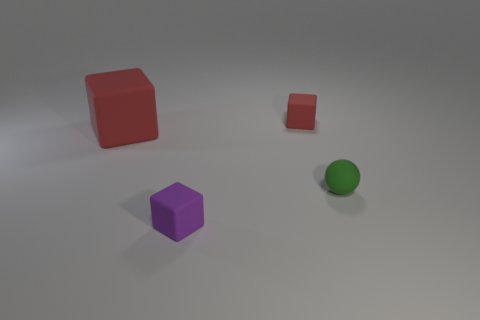Do the tiny sphere and the red object left of the small red object have the same material?
Your answer should be compact. Yes. What is the shape of the green thing behind the purple thing?
Offer a very short reply. Sphere. Is the number of matte things the same as the number of tiny red balls?
Make the answer very short. No. How many other objects are there of the same material as the small sphere?
Provide a succinct answer. 3. How big is the purple rubber block?
Provide a short and direct response. Small. What number of other things are there of the same color as the small ball?
Make the answer very short. 0. The matte object that is both behind the green rubber thing and on the right side of the purple cube is what color?
Keep it short and to the point. Red. What number of small purple cubes are there?
Offer a terse response. 1. Is the material of the big red block the same as the tiny red cube?
Your answer should be very brief. Yes. What shape is the thing behind the red rubber block left of the tiny cube on the left side of the small red rubber thing?
Keep it short and to the point. Cube. 